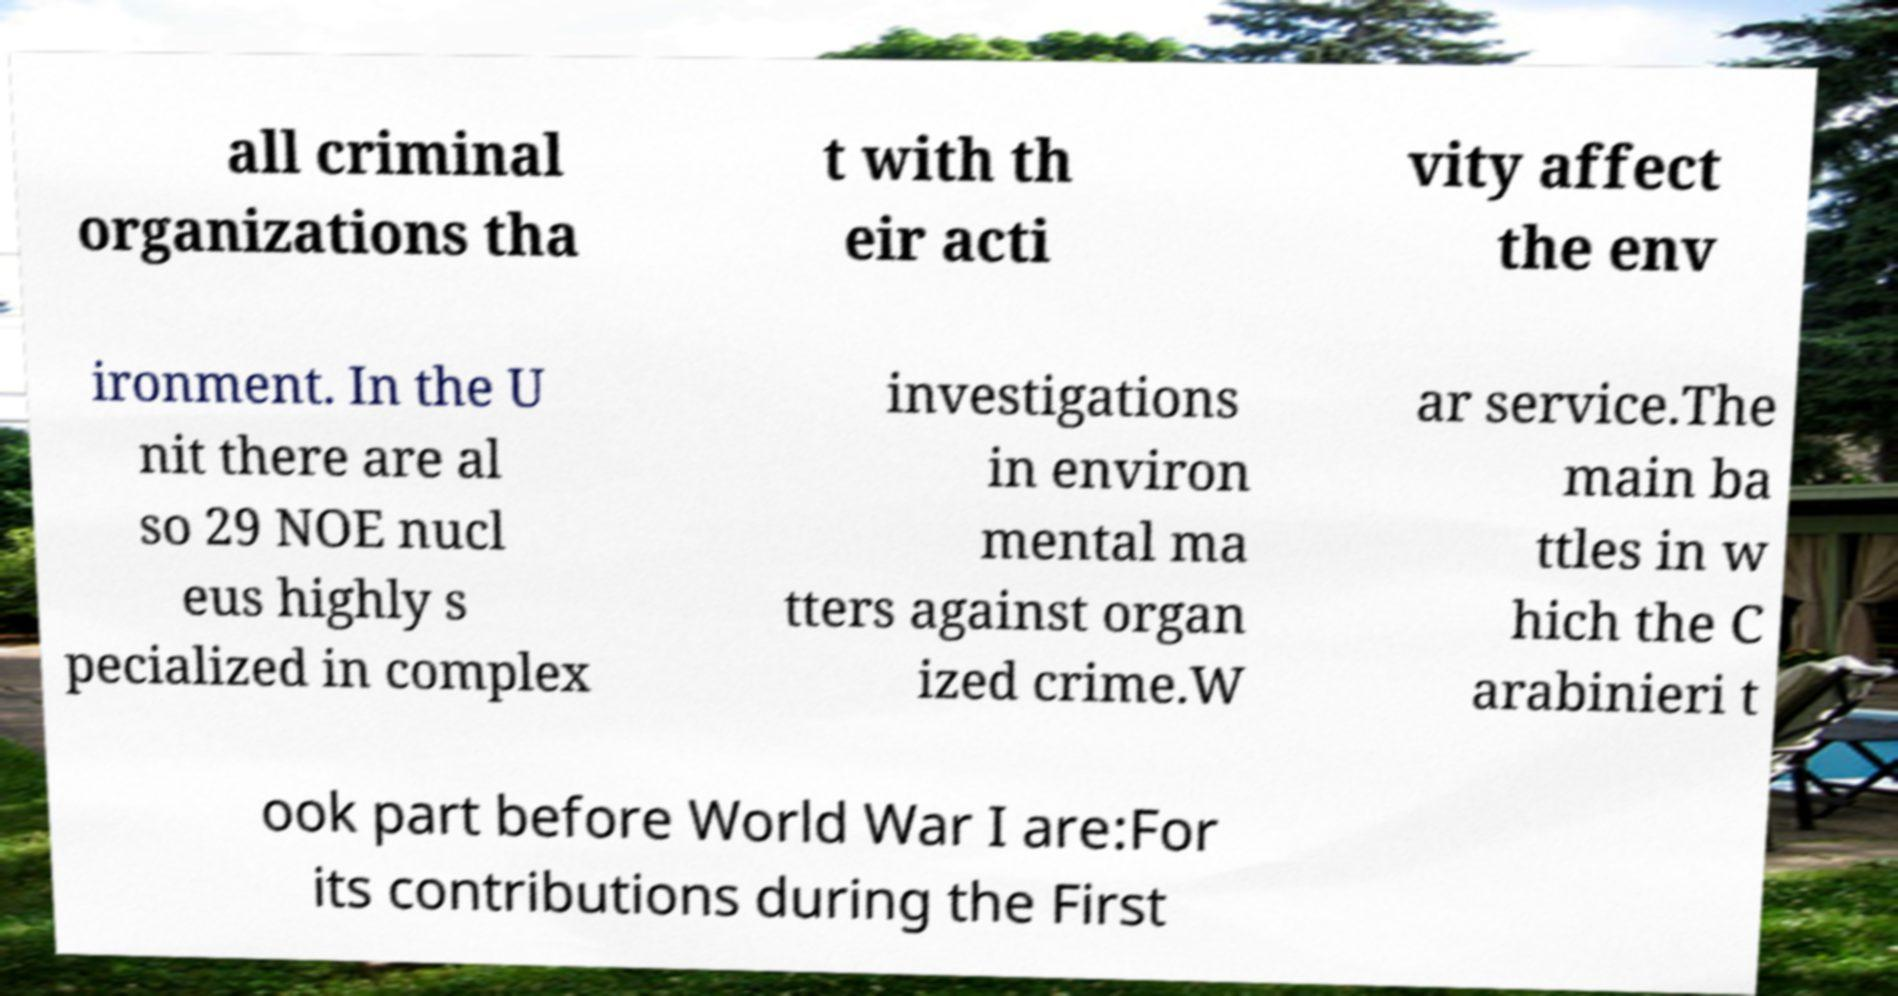Could you assist in decoding the text presented in this image and type it out clearly? all criminal organizations tha t with th eir acti vity affect the env ironment. In the U nit there are al so 29 NOE nucl eus highly s pecialized in complex investigations in environ mental ma tters against organ ized crime.W ar service.The main ba ttles in w hich the C arabinieri t ook part before World War I are:For its contributions during the First 